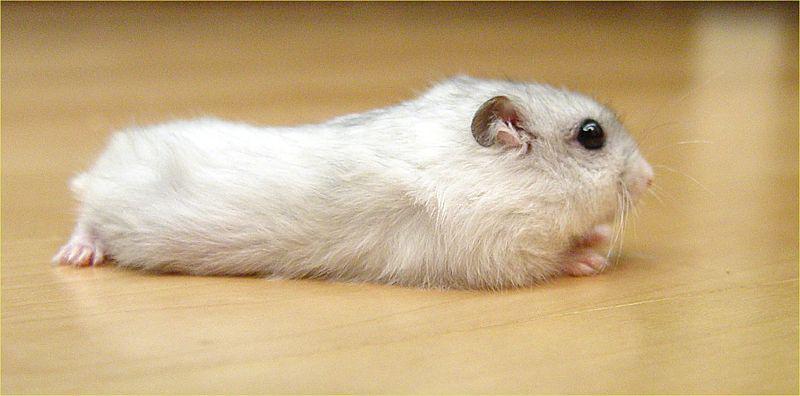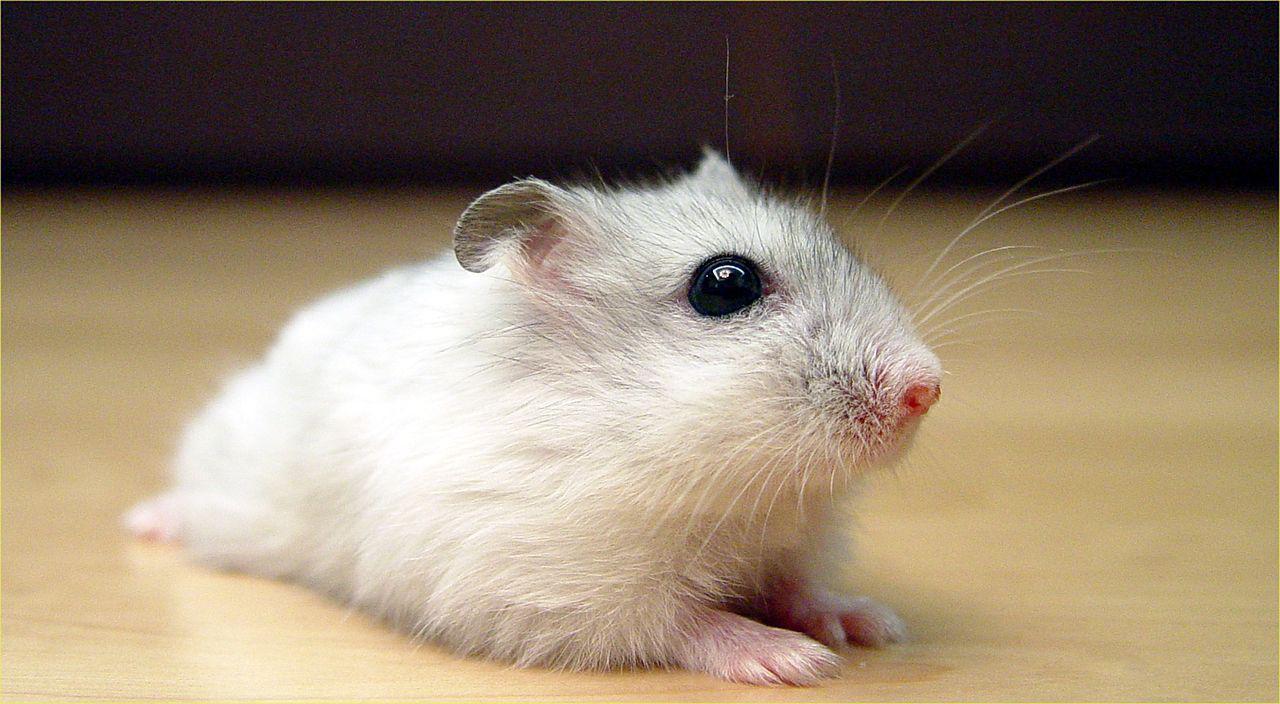The first image is the image on the left, the second image is the image on the right. Analyze the images presented: Is the assertion "A single rodent is lying down on a smooth surface in the image on the right." valid? Answer yes or no. Yes. The first image is the image on the left, the second image is the image on the right. Analyze the images presented: Is the assertion "Each image contains a single hamster, and at least one hamster is standing upright with its front paws in front of its body." valid? Answer yes or no. No. 